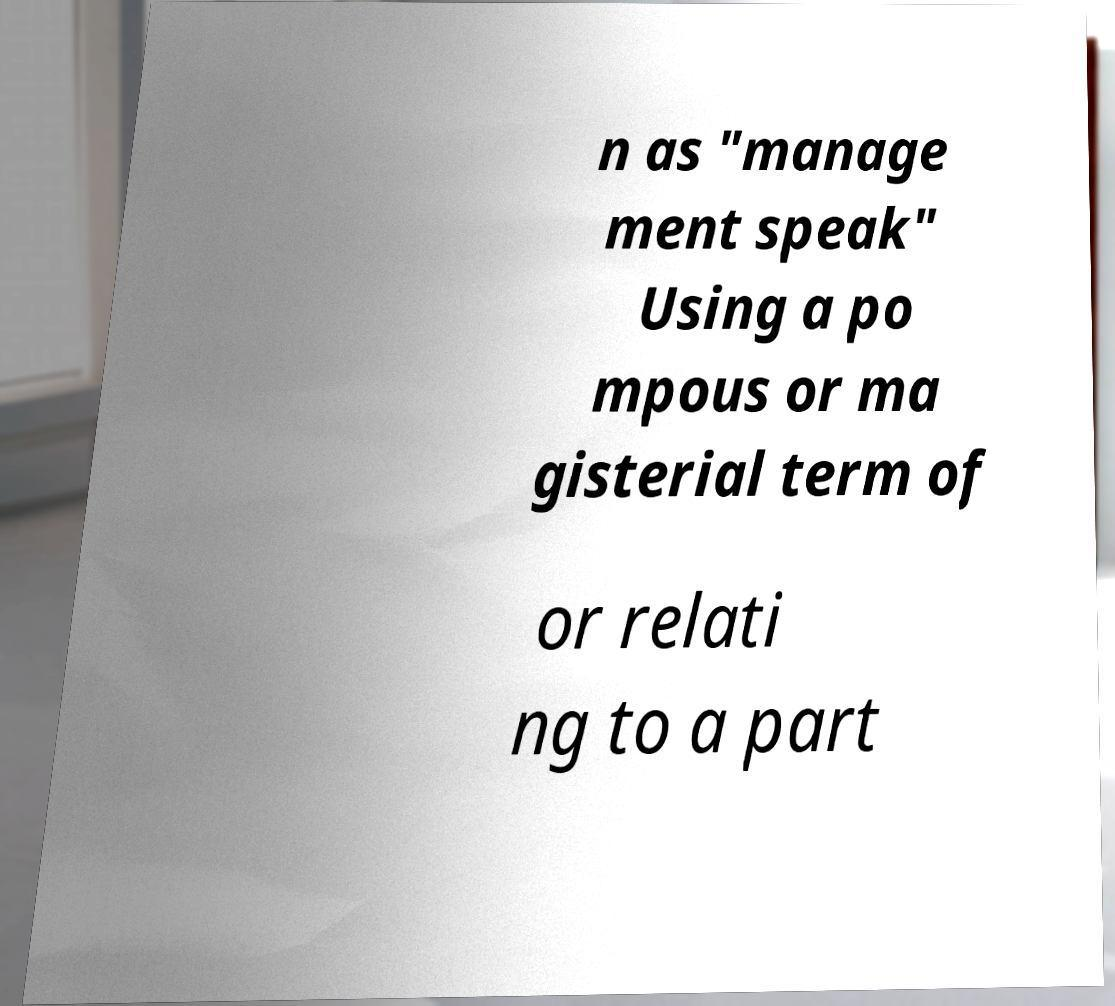I need the written content from this picture converted into text. Can you do that? n as "manage ment speak" Using a po mpous or ma gisterial term of or relati ng to a part 